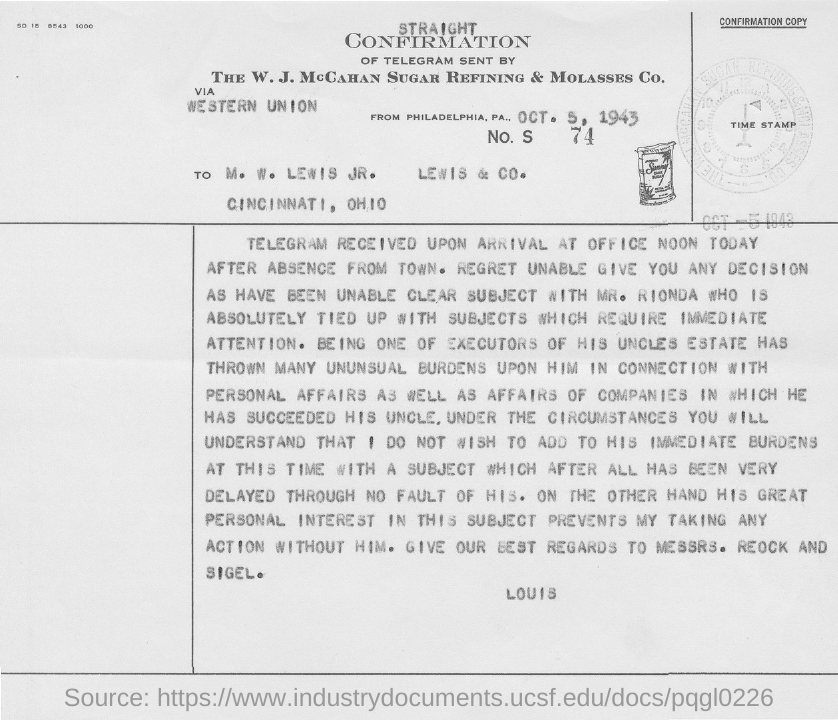To Whom is this letter addressed to?
Offer a terse response. M. W. LEWIS JR. Give best regards to whom?
Ensure brevity in your answer.  Messrs. Reock and Sigel. 